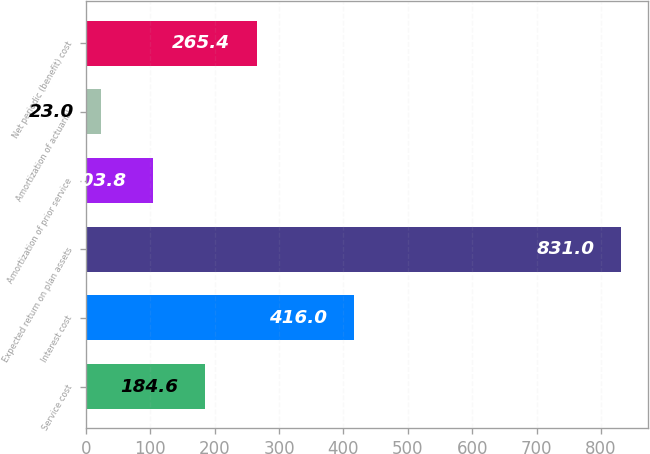Convert chart to OTSL. <chart><loc_0><loc_0><loc_500><loc_500><bar_chart><fcel>Service cost<fcel>Interest cost<fcel>Expected return on plan assets<fcel>Amortization of prior service<fcel>Amortization of actuarial<fcel>Net periodic (benefit) cost<nl><fcel>184.6<fcel>416<fcel>831<fcel>103.8<fcel>23<fcel>265.4<nl></chart> 